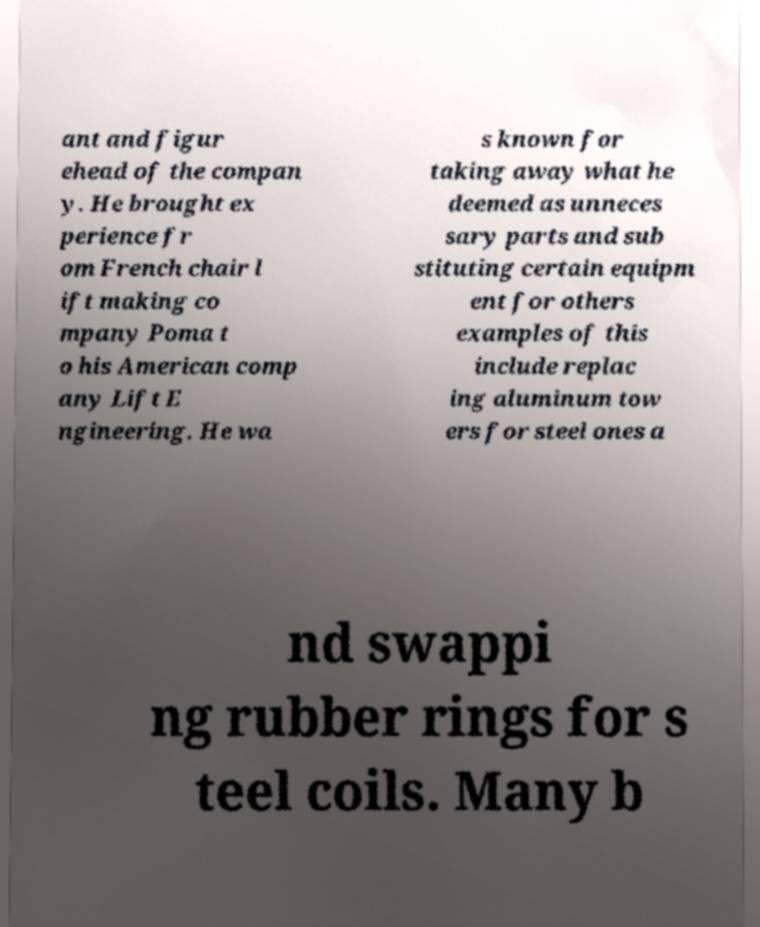There's text embedded in this image that I need extracted. Can you transcribe it verbatim? ant and figur ehead of the compan y. He brought ex perience fr om French chair l ift making co mpany Poma t o his American comp any Lift E ngineering. He wa s known for taking away what he deemed as unneces sary parts and sub stituting certain equipm ent for others examples of this include replac ing aluminum tow ers for steel ones a nd swappi ng rubber rings for s teel coils. Many b 